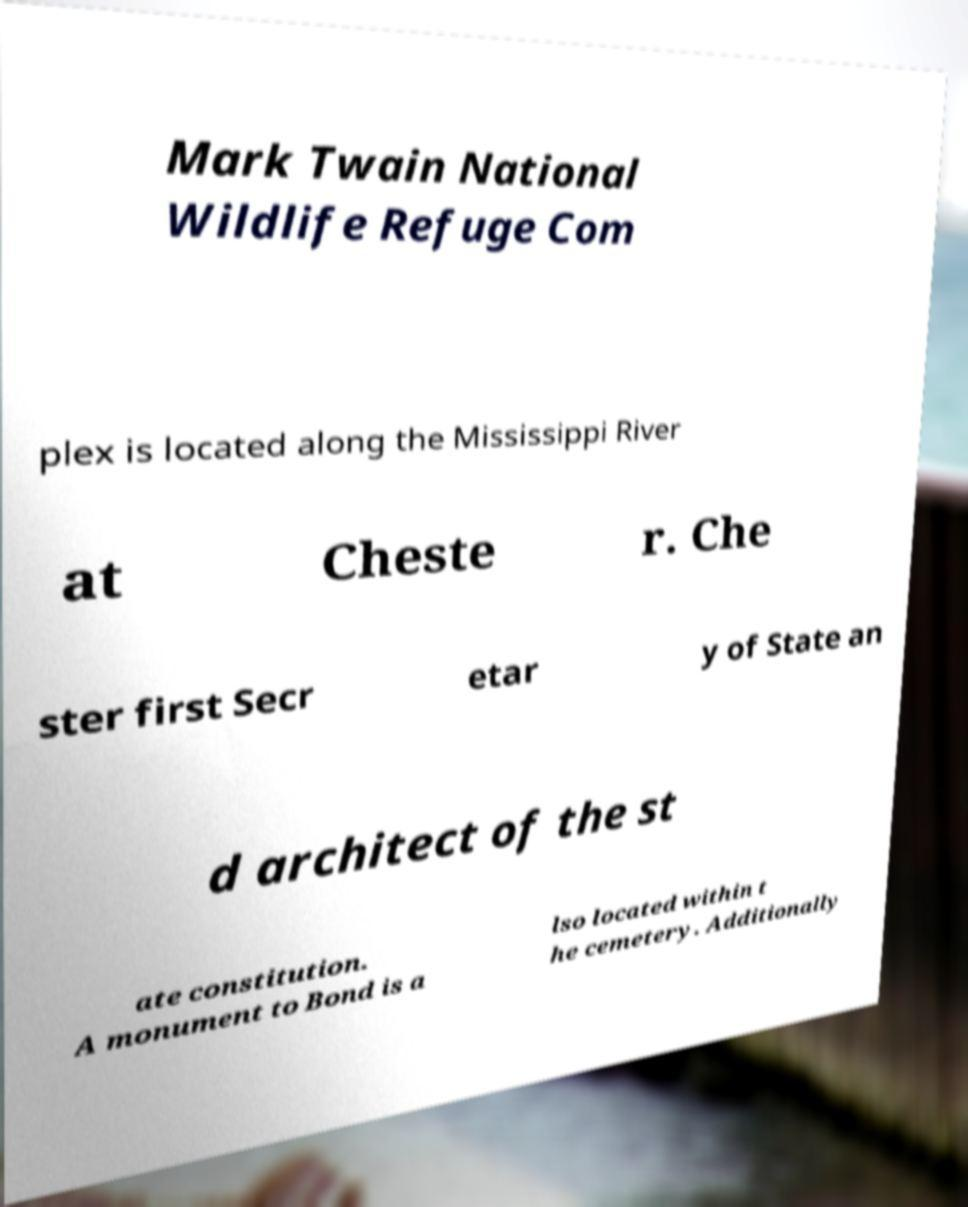For documentation purposes, I need the text within this image transcribed. Could you provide that? Mark Twain National Wildlife Refuge Com plex is located along the Mississippi River at Cheste r. Che ster first Secr etar y of State an d architect of the st ate constitution. A monument to Bond is a lso located within t he cemetery. Additionally 